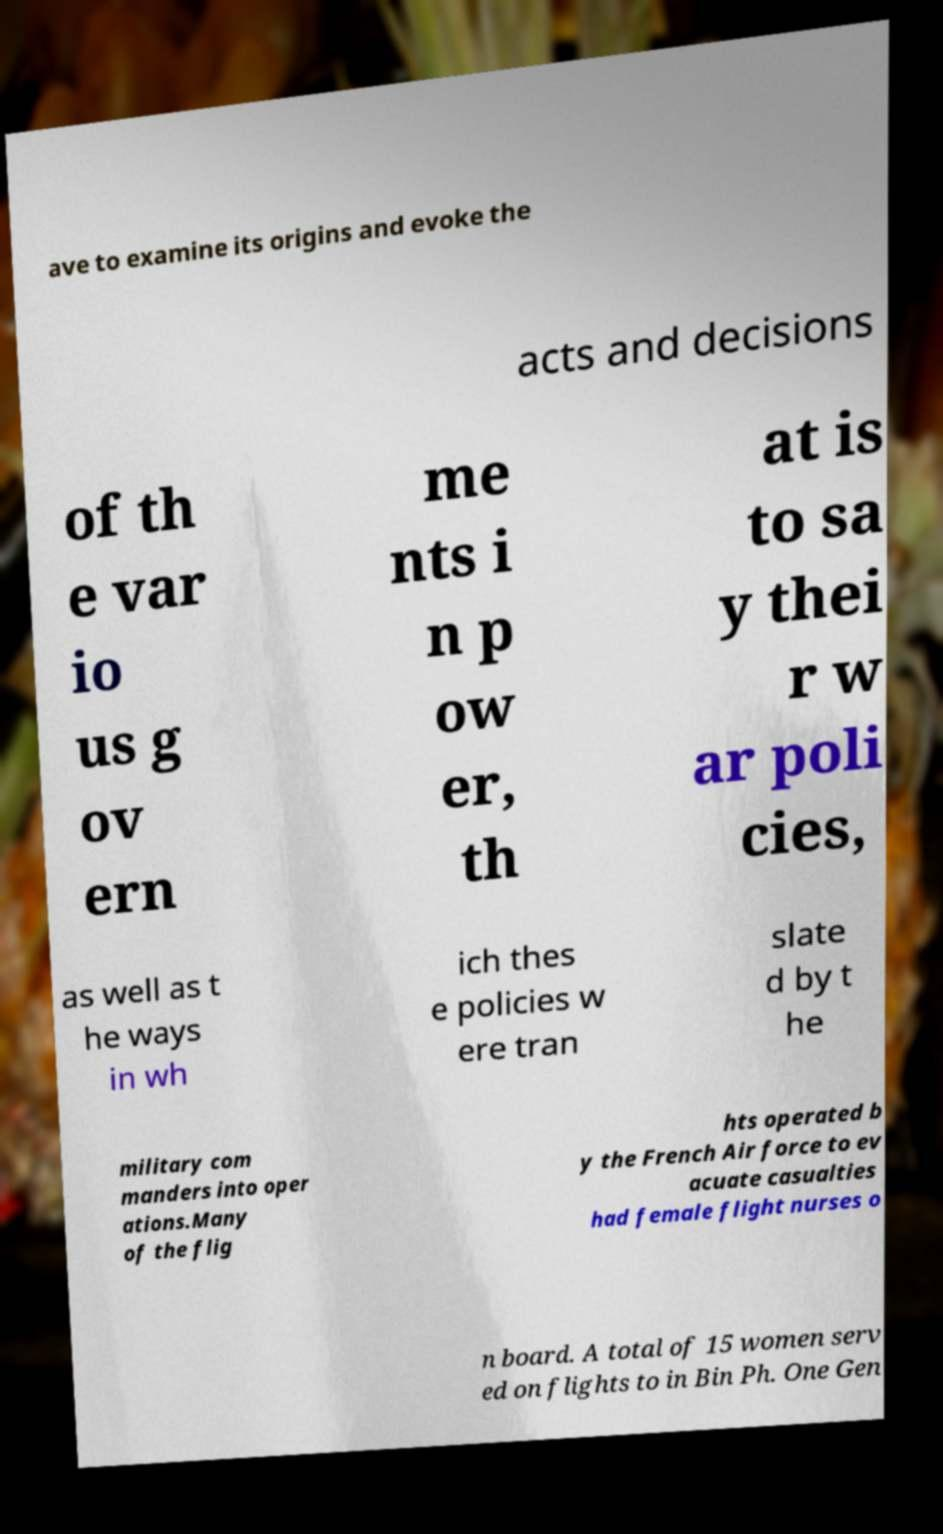I need the written content from this picture converted into text. Can you do that? ave to examine its origins and evoke the acts and decisions of th e var io us g ov ern me nts i n p ow er, th at is to sa y thei r w ar poli cies, as well as t he ways in wh ich thes e policies w ere tran slate d by t he military com manders into oper ations.Many of the flig hts operated b y the French Air force to ev acuate casualties had female flight nurses o n board. A total of 15 women serv ed on flights to in Bin Ph. One Gen 